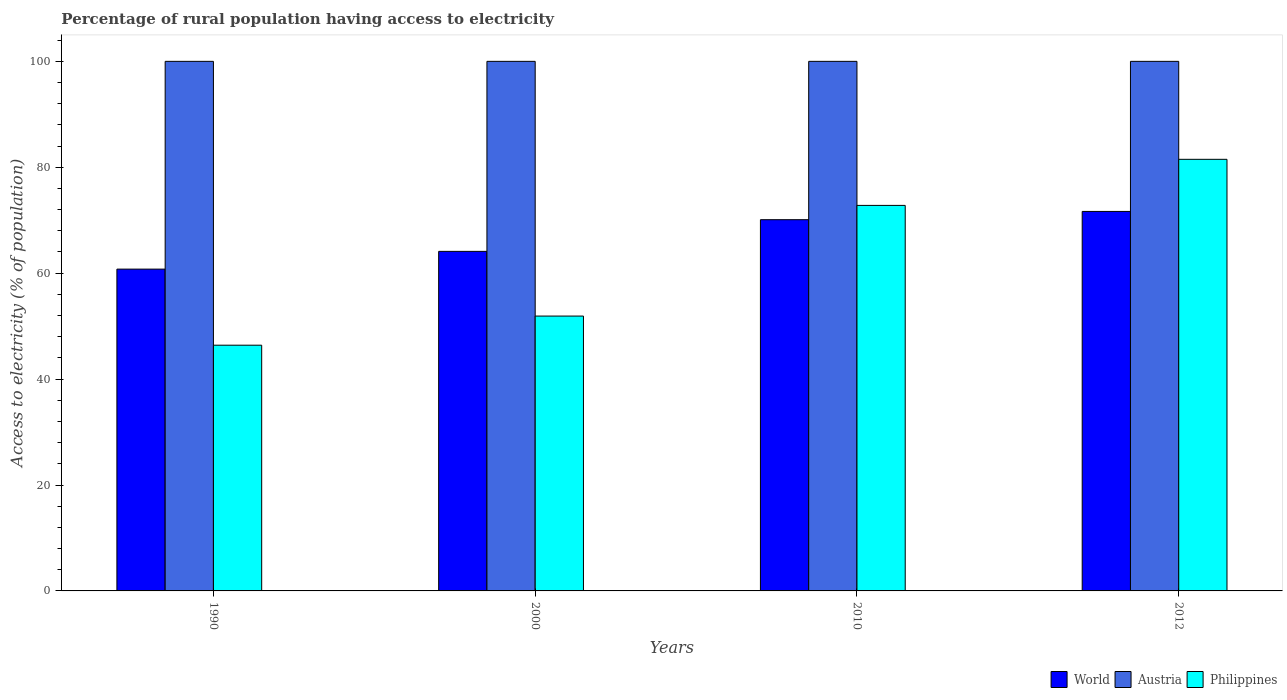How many groups of bars are there?
Your answer should be very brief. 4. Are the number of bars per tick equal to the number of legend labels?
Provide a succinct answer. Yes. Are the number of bars on each tick of the X-axis equal?
Provide a succinct answer. Yes. What is the label of the 3rd group of bars from the left?
Give a very brief answer. 2010. In how many cases, is the number of bars for a given year not equal to the number of legend labels?
Your answer should be compact. 0. What is the percentage of rural population having access to electricity in World in 2012?
Offer a terse response. 71.66. Across all years, what is the maximum percentage of rural population having access to electricity in World?
Your answer should be compact. 71.66. Across all years, what is the minimum percentage of rural population having access to electricity in Philippines?
Give a very brief answer. 46.4. In which year was the percentage of rural population having access to electricity in Philippines maximum?
Offer a very short reply. 2012. In which year was the percentage of rural population having access to electricity in Austria minimum?
Offer a terse response. 1990. What is the total percentage of rural population having access to electricity in Philippines in the graph?
Your answer should be compact. 252.6. What is the difference between the percentage of rural population having access to electricity in World in 2010 and the percentage of rural population having access to electricity in Philippines in 2012?
Make the answer very short. -11.4. What is the average percentage of rural population having access to electricity in Philippines per year?
Your answer should be very brief. 63.15. In the year 1990, what is the difference between the percentage of rural population having access to electricity in Austria and percentage of rural population having access to electricity in Philippines?
Provide a succinct answer. 53.6. What is the ratio of the percentage of rural population having access to electricity in Philippines in 2000 to that in 2012?
Offer a very short reply. 0.64. What is the difference between the highest and the second highest percentage of rural population having access to electricity in Philippines?
Provide a short and direct response. 8.7. What is the difference between the highest and the lowest percentage of rural population having access to electricity in Philippines?
Provide a succinct answer. 35.1. In how many years, is the percentage of rural population having access to electricity in World greater than the average percentage of rural population having access to electricity in World taken over all years?
Ensure brevity in your answer.  2. What does the 1st bar from the left in 1990 represents?
Your answer should be compact. World. What does the 1st bar from the right in 2012 represents?
Your answer should be very brief. Philippines. Is it the case that in every year, the sum of the percentage of rural population having access to electricity in World and percentage of rural population having access to electricity in Philippines is greater than the percentage of rural population having access to electricity in Austria?
Make the answer very short. Yes. How many bars are there?
Provide a short and direct response. 12. Are the values on the major ticks of Y-axis written in scientific E-notation?
Your answer should be compact. No. Does the graph contain grids?
Give a very brief answer. No. How are the legend labels stacked?
Your answer should be compact. Horizontal. What is the title of the graph?
Provide a short and direct response. Percentage of rural population having access to electricity. Does "Nigeria" appear as one of the legend labels in the graph?
Ensure brevity in your answer.  No. What is the label or title of the Y-axis?
Offer a terse response. Access to electricity (% of population). What is the Access to electricity (% of population) of World in 1990?
Make the answer very short. 60.77. What is the Access to electricity (% of population) in Philippines in 1990?
Your answer should be compact. 46.4. What is the Access to electricity (% of population) in World in 2000?
Provide a short and direct response. 64.12. What is the Access to electricity (% of population) of Philippines in 2000?
Keep it short and to the point. 51.9. What is the Access to electricity (% of population) in World in 2010?
Offer a terse response. 70.1. What is the Access to electricity (% of population) in Austria in 2010?
Provide a succinct answer. 100. What is the Access to electricity (% of population) of Philippines in 2010?
Give a very brief answer. 72.8. What is the Access to electricity (% of population) of World in 2012?
Give a very brief answer. 71.66. What is the Access to electricity (% of population) in Austria in 2012?
Offer a very short reply. 100. What is the Access to electricity (% of population) in Philippines in 2012?
Your answer should be very brief. 81.5. Across all years, what is the maximum Access to electricity (% of population) in World?
Your answer should be very brief. 71.66. Across all years, what is the maximum Access to electricity (% of population) of Austria?
Offer a very short reply. 100. Across all years, what is the maximum Access to electricity (% of population) of Philippines?
Your answer should be very brief. 81.5. Across all years, what is the minimum Access to electricity (% of population) of World?
Your response must be concise. 60.77. Across all years, what is the minimum Access to electricity (% of population) in Austria?
Provide a short and direct response. 100. Across all years, what is the minimum Access to electricity (% of population) of Philippines?
Give a very brief answer. 46.4. What is the total Access to electricity (% of population) in World in the graph?
Make the answer very short. 266.65. What is the total Access to electricity (% of population) in Philippines in the graph?
Offer a terse response. 252.6. What is the difference between the Access to electricity (% of population) of World in 1990 and that in 2000?
Offer a terse response. -3.35. What is the difference between the Access to electricity (% of population) in Austria in 1990 and that in 2000?
Keep it short and to the point. 0. What is the difference between the Access to electricity (% of population) in Philippines in 1990 and that in 2000?
Your response must be concise. -5.5. What is the difference between the Access to electricity (% of population) in World in 1990 and that in 2010?
Keep it short and to the point. -9.34. What is the difference between the Access to electricity (% of population) in Philippines in 1990 and that in 2010?
Provide a succinct answer. -26.4. What is the difference between the Access to electricity (% of population) of World in 1990 and that in 2012?
Your answer should be compact. -10.89. What is the difference between the Access to electricity (% of population) of Austria in 1990 and that in 2012?
Your response must be concise. 0. What is the difference between the Access to electricity (% of population) of Philippines in 1990 and that in 2012?
Ensure brevity in your answer.  -35.1. What is the difference between the Access to electricity (% of population) of World in 2000 and that in 2010?
Give a very brief answer. -5.98. What is the difference between the Access to electricity (% of population) in Philippines in 2000 and that in 2010?
Offer a very short reply. -20.9. What is the difference between the Access to electricity (% of population) of World in 2000 and that in 2012?
Offer a very short reply. -7.54. What is the difference between the Access to electricity (% of population) of Austria in 2000 and that in 2012?
Provide a short and direct response. 0. What is the difference between the Access to electricity (% of population) in Philippines in 2000 and that in 2012?
Provide a succinct answer. -29.6. What is the difference between the Access to electricity (% of population) in World in 2010 and that in 2012?
Provide a short and direct response. -1.56. What is the difference between the Access to electricity (% of population) in Philippines in 2010 and that in 2012?
Provide a succinct answer. -8.7. What is the difference between the Access to electricity (% of population) in World in 1990 and the Access to electricity (% of population) in Austria in 2000?
Provide a succinct answer. -39.23. What is the difference between the Access to electricity (% of population) in World in 1990 and the Access to electricity (% of population) in Philippines in 2000?
Keep it short and to the point. 8.87. What is the difference between the Access to electricity (% of population) of Austria in 1990 and the Access to electricity (% of population) of Philippines in 2000?
Offer a terse response. 48.1. What is the difference between the Access to electricity (% of population) in World in 1990 and the Access to electricity (% of population) in Austria in 2010?
Your response must be concise. -39.23. What is the difference between the Access to electricity (% of population) of World in 1990 and the Access to electricity (% of population) of Philippines in 2010?
Make the answer very short. -12.03. What is the difference between the Access to electricity (% of population) of Austria in 1990 and the Access to electricity (% of population) of Philippines in 2010?
Ensure brevity in your answer.  27.2. What is the difference between the Access to electricity (% of population) of World in 1990 and the Access to electricity (% of population) of Austria in 2012?
Your response must be concise. -39.23. What is the difference between the Access to electricity (% of population) of World in 1990 and the Access to electricity (% of population) of Philippines in 2012?
Ensure brevity in your answer.  -20.73. What is the difference between the Access to electricity (% of population) of World in 2000 and the Access to electricity (% of population) of Austria in 2010?
Keep it short and to the point. -35.88. What is the difference between the Access to electricity (% of population) of World in 2000 and the Access to electricity (% of population) of Philippines in 2010?
Keep it short and to the point. -8.68. What is the difference between the Access to electricity (% of population) in Austria in 2000 and the Access to electricity (% of population) in Philippines in 2010?
Make the answer very short. 27.2. What is the difference between the Access to electricity (% of population) of World in 2000 and the Access to electricity (% of population) of Austria in 2012?
Give a very brief answer. -35.88. What is the difference between the Access to electricity (% of population) of World in 2000 and the Access to electricity (% of population) of Philippines in 2012?
Your answer should be very brief. -17.38. What is the difference between the Access to electricity (% of population) in World in 2010 and the Access to electricity (% of population) in Austria in 2012?
Your response must be concise. -29.9. What is the difference between the Access to electricity (% of population) of World in 2010 and the Access to electricity (% of population) of Philippines in 2012?
Give a very brief answer. -11.4. What is the average Access to electricity (% of population) of World per year?
Offer a terse response. 66.66. What is the average Access to electricity (% of population) of Austria per year?
Your response must be concise. 100. What is the average Access to electricity (% of population) in Philippines per year?
Ensure brevity in your answer.  63.15. In the year 1990, what is the difference between the Access to electricity (% of population) of World and Access to electricity (% of population) of Austria?
Offer a terse response. -39.23. In the year 1990, what is the difference between the Access to electricity (% of population) of World and Access to electricity (% of population) of Philippines?
Offer a terse response. 14.37. In the year 1990, what is the difference between the Access to electricity (% of population) of Austria and Access to electricity (% of population) of Philippines?
Make the answer very short. 53.6. In the year 2000, what is the difference between the Access to electricity (% of population) of World and Access to electricity (% of population) of Austria?
Provide a succinct answer. -35.88. In the year 2000, what is the difference between the Access to electricity (% of population) of World and Access to electricity (% of population) of Philippines?
Give a very brief answer. 12.22. In the year 2000, what is the difference between the Access to electricity (% of population) of Austria and Access to electricity (% of population) of Philippines?
Offer a very short reply. 48.1. In the year 2010, what is the difference between the Access to electricity (% of population) of World and Access to electricity (% of population) of Austria?
Provide a short and direct response. -29.9. In the year 2010, what is the difference between the Access to electricity (% of population) of World and Access to electricity (% of population) of Philippines?
Give a very brief answer. -2.7. In the year 2010, what is the difference between the Access to electricity (% of population) of Austria and Access to electricity (% of population) of Philippines?
Provide a short and direct response. 27.2. In the year 2012, what is the difference between the Access to electricity (% of population) of World and Access to electricity (% of population) of Austria?
Your answer should be compact. -28.34. In the year 2012, what is the difference between the Access to electricity (% of population) of World and Access to electricity (% of population) of Philippines?
Your answer should be compact. -9.84. What is the ratio of the Access to electricity (% of population) in World in 1990 to that in 2000?
Your response must be concise. 0.95. What is the ratio of the Access to electricity (% of population) in Philippines in 1990 to that in 2000?
Keep it short and to the point. 0.89. What is the ratio of the Access to electricity (% of population) of World in 1990 to that in 2010?
Provide a short and direct response. 0.87. What is the ratio of the Access to electricity (% of population) in Philippines in 1990 to that in 2010?
Provide a short and direct response. 0.64. What is the ratio of the Access to electricity (% of population) of World in 1990 to that in 2012?
Give a very brief answer. 0.85. What is the ratio of the Access to electricity (% of population) of Philippines in 1990 to that in 2012?
Give a very brief answer. 0.57. What is the ratio of the Access to electricity (% of population) in World in 2000 to that in 2010?
Give a very brief answer. 0.91. What is the ratio of the Access to electricity (% of population) in Austria in 2000 to that in 2010?
Your response must be concise. 1. What is the ratio of the Access to electricity (% of population) in Philippines in 2000 to that in 2010?
Keep it short and to the point. 0.71. What is the ratio of the Access to electricity (% of population) of World in 2000 to that in 2012?
Give a very brief answer. 0.89. What is the ratio of the Access to electricity (% of population) in Austria in 2000 to that in 2012?
Provide a succinct answer. 1. What is the ratio of the Access to electricity (% of population) of Philippines in 2000 to that in 2012?
Provide a short and direct response. 0.64. What is the ratio of the Access to electricity (% of population) in World in 2010 to that in 2012?
Give a very brief answer. 0.98. What is the ratio of the Access to electricity (% of population) in Austria in 2010 to that in 2012?
Ensure brevity in your answer.  1. What is the ratio of the Access to electricity (% of population) in Philippines in 2010 to that in 2012?
Provide a succinct answer. 0.89. What is the difference between the highest and the second highest Access to electricity (% of population) of World?
Make the answer very short. 1.56. What is the difference between the highest and the lowest Access to electricity (% of population) of World?
Offer a very short reply. 10.89. What is the difference between the highest and the lowest Access to electricity (% of population) of Philippines?
Your answer should be compact. 35.1. 